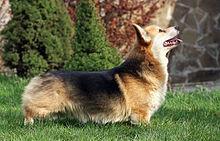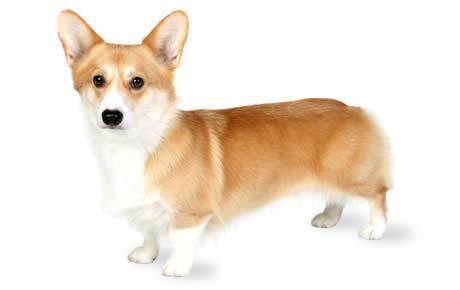The first image is the image on the left, the second image is the image on the right. Assess this claim about the two images: "There is no more than one dog standing on grass in the left image.". Correct or not? Answer yes or no. Yes. The first image is the image on the left, the second image is the image on the right. For the images shown, is this caption "In at least one of the images, the corgi is NOT on the grass." true? Answer yes or no. Yes. 